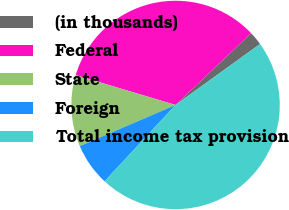Convert chart to OTSL. <chart><loc_0><loc_0><loc_500><loc_500><pie_chart><fcel>(in thousands)<fcel>Federal<fcel>State<fcel>Foreign<fcel>Total income tax provision<nl><fcel>2.14%<fcel>33.28%<fcel>11.09%<fcel>6.61%<fcel>46.88%<nl></chart> 